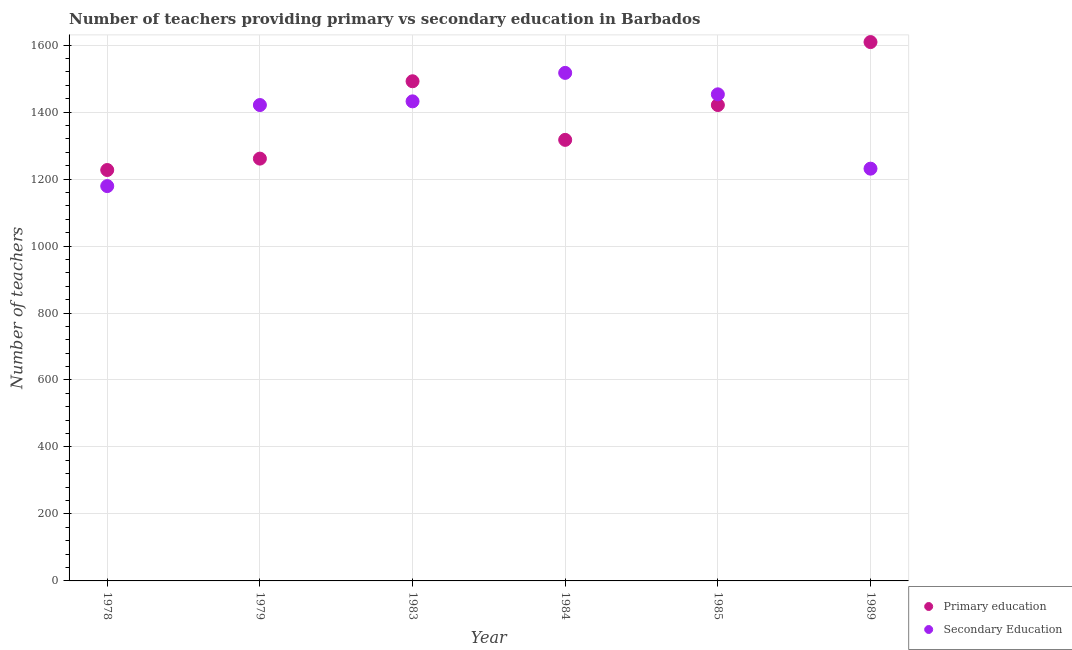How many different coloured dotlines are there?
Your response must be concise. 2. Is the number of dotlines equal to the number of legend labels?
Keep it short and to the point. Yes. What is the number of secondary teachers in 1979?
Make the answer very short. 1421. Across all years, what is the maximum number of primary teachers?
Your answer should be very brief. 1609. Across all years, what is the minimum number of secondary teachers?
Offer a terse response. 1179. In which year was the number of secondary teachers maximum?
Ensure brevity in your answer.  1984. In which year was the number of primary teachers minimum?
Make the answer very short. 1978. What is the total number of secondary teachers in the graph?
Your response must be concise. 8233. What is the difference between the number of primary teachers in 1979 and that in 1985?
Your answer should be compact. -160. What is the difference between the number of secondary teachers in 1989 and the number of primary teachers in 1978?
Provide a short and direct response. 4. What is the average number of primary teachers per year?
Provide a succinct answer. 1387.83. In the year 1989, what is the difference between the number of secondary teachers and number of primary teachers?
Your answer should be compact. -378. In how many years, is the number of secondary teachers greater than 1040?
Give a very brief answer. 6. What is the ratio of the number of primary teachers in 1978 to that in 1983?
Your answer should be very brief. 0.82. Is the difference between the number of secondary teachers in 1978 and 1985 greater than the difference between the number of primary teachers in 1978 and 1985?
Your answer should be compact. No. What is the difference between the highest and the second highest number of primary teachers?
Give a very brief answer. 117. What is the difference between the highest and the lowest number of primary teachers?
Your answer should be very brief. 382. Is the sum of the number of secondary teachers in 1978 and 1983 greater than the maximum number of primary teachers across all years?
Make the answer very short. Yes. Does the number of primary teachers monotonically increase over the years?
Offer a terse response. No. Is the number of primary teachers strictly greater than the number of secondary teachers over the years?
Ensure brevity in your answer.  No. Is the number of secondary teachers strictly less than the number of primary teachers over the years?
Provide a short and direct response. No. How many dotlines are there?
Offer a very short reply. 2. Are the values on the major ticks of Y-axis written in scientific E-notation?
Make the answer very short. No. Does the graph contain grids?
Your response must be concise. Yes. How many legend labels are there?
Offer a terse response. 2. How are the legend labels stacked?
Your answer should be compact. Vertical. What is the title of the graph?
Provide a succinct answer. Number of teachers providing primary vs secondary education in Barbados. What is the label or title of the Y-axis?
Offer a terse response. Number of teachers. What is the Number of teachers of Primary education in 1978?
Give a very brief answer. 1227. What is the Number of teachers of Secondary Education in 1978?
Offer a very short reply. 1179. What is the Number of teachers of Primary education in 1979?
Give a very brief answer. 1261. What is the Number of teachers in Secondary Education in 1979?
Make the answer very short. 1421. What is the Number of teachers in Primary education in 1983?
Your response must be concise. 1492. What is the Number of teachers of Secondary Education in 1983?
Give a very brief answer. 1432. What is the Number of teachers in Primary education in 1984?
Your answer should be compact. 1317. What is the Number of teachers of Secondary Education in 1984?
Your response must be concise. 1517. What is the Number of teachers of Primary education in 1985?
Offer a terse response. 1421. What is the Number of teachers of Secondary Education in 1985?
Give a very brief answer. 1453. What is the Number of teachers of Primary education in 1989?
Your answer should be compact. 1609. What is the Number of teachers of Secondary Education in 1989?
Offer a very short reply. 1231. Across all years, what is the maximum Number of teachers of Primary education?
Your response must be concise. 1609. Across all years, what is the maximum Number of teachers in Secondary Education?
Make the answer very short. 1517. Across all years, what is the minimum Number of teachers in Primary education?
Give a very brief answer. 1227. Across all years, what is the minimum Number of teachers of Secondary Education?
Provide a succinct answer. 1179. What is the total Number of teachers of Primary education in the graph?
Your response must be concise. 8327. What is the total Number of teachers in Secondary Education in the graph?
Your response must be concise. 8233. What is the difference between the Number of teachers in Primary education in 1978 and that in 1979?
Offer a terse response. -34. What is the difference between the Number of teachers of Secondary Education in 1978 and that in 1979?
Your answer should be very brief. -242. What is the difference between the Number of teachers of Primary education in 1978 and that in 1983?
Ensure brevity in your answer.  -265. What is the difference between the Number of teachers of Secondary Education in 1978 and that in 1983?
Your answer should be very brief. -253. What is the difference between the Number of teachers of Primary education in 1978 and that in 1984?
Ensure brevity in your answer.  -90. What is the difference between the Number of teachers of Secondary Education in 1978 and that in 1984?
Make the answer very short. -338. What is the difference between the Number of teachers of Primary education in 1978 and that in 1985?
Provide a short and direct response. -194. What is the difference between the Number of teachers of Secondary Education in 1978 and that in 1985?
Keep it short and to the point. -274. What is the difference between the Number of teachers in Primary education in 1978 and that in 1989?
Give a very brief answer. -382. What is the difference between the Number of teachers of Secondary Education in 1978 and that in 1989?
Ensure brevity in your answer.  -52. What is the difference between the Number of teachers in Primary education in 1979 and that in 1983?
Give a very brief answer. -231. What is the difference between the Number of teachers in Primary education in 1979 and that in 1984?
Ensure brevity in your answer.  -56. What is the difference between the Number of teachers of Secondary Education in 1979 and that in 1984?
Ensure brevity in your answer.  -96. What is the difference between the Number of teachers in Primary education in 1979 and that in 1985?
Offer a terse response. -160. What is the difference between the Number of teachers in Secondary Education in 1979 and that in 1985?
Provide a succinct answer. -32. What is the difference between the Number of teachers in Primary education in 1979 and that in 1989?
Make the answer very short. -348. What is the difference between the Number of teachers in Secondary Education in 1979 and that in 1989?
Offer a terse response. 190. What is the difference between the Number of teachers of Primary education in 1983 and that in 1984?
Your response must be concise. 175. What is the difference between the Number of teachers in Secondary Education in 1983 and that in 1984?
Offer a terse response. -85. What is the difference between the Number of teachers in Secondary Education in 1983 and that in 1985?
Keep it short and to the point. -21. What is the difference between the Number of teachers in Primary education in 1983 and that in 1989?
Ensure brevity in your answer.  -117. What is the difference between the Number of teachers in Secondary Education in 1983 and that in 1989?
Your answer should be very brief. 201. What is the difference between the Number of teachers in Primary education in 1984 and that in 1985?
Provide a succinct answer. -104. What is the difference between the Number of teachers in Secondary Education in 1984 and that in 1985?
Provide a succinct answer. 64. What is the difference between the Number of teachers of Primary education in 1984 and that in 1989?
Make the answer very short. -292. What is the difference between the Number of teachers of Secondary Education in 1984 and that in 1989?
Give a very brief answer. 286. What is the difference between the Number of teachers of Primary education in 1985 and that in 1989?
Your answer should be very brief. -188. What is the difference between the Number of teachers of Secondary Education in 1985 and that in 1989?
Provide a short and direct response. 222. What is the difference between the Number of teachers in Primary education in 1978 and the Number of teachers in Secondary Education in 1979?
Provide a succinct answer. -194. What is the difference between the Number of teachers in Primary education in 1978 and the Number of teachers in Secondary Education in 1983?
Make the answer very short. -205. What is the difference between the Number of teachers of Primary education in 1978 and the Number of teachers of Secondary Education in 1984?
Your answer should be compact. -290. What is the difference between the Number of teachers in Primary education in 1978 and the Number of teachers in Secondary Education in 1985?
Your answer should be compact. -226. What is the difference between the Number of teachers of Primary education in 1979 and the Number of teachers of Secondary Education in 1983?
Keep it short and to the point. -171. What is the difference between the Number of teachers in Primary education in 1979 and the Number of teachers in Secondary Education in 1984?
Make the answer very short. -256. What is the difference between the Number of teachers in Primary education in 1979 and the Number of teachers in Secondary Education in 1985?
Give a very brief answer. -192. What is the difference between the Number of teachers of Primary education in 1979 and the Number of teachers of Secondary Education in 1989?
Ensure brevity in your answer.  30. What is the difference between the Number of teachers of Primary education in 1983 and the Number of teachers of Secondary Education in 1989?
Offer a very short reply. 261. What is the difference between the Number of teachers in Primary education in 1984 and the Number of teachers in Secondary Education in 1985?
Make the answer very short. -136. What is the difference between the Number of teachers in Primary education in 1984 and the Number of teachers in Secondary Education in 1989?
Give a very brief answer. 86. What is the difference between the Number of teachers in Primary education in 1985 and the Number of teachers in Secondary Education in 1989?
Ensure brevity in your answer.  190. What is the average Number of teachers of Primary education per year?
Provide a succinct answer. 1387.83. What is the average Number of teachers of Secondary Education per year?
Make the answer very short. 1372.17. In the year 1978, what is the difference between the Number of teachers of Primary education and Number of teachers of Secondary Education?
Provide a short and direct response. 48. In the year 1979, what is the difference between the Number of teachers of Primary education and Number of teachers of Secondary Education?
Ensure brevity in your answer.  -160. In the year 1984, what is the difference between the Number of teachers in Primary education and Number of teachers in Secondary Education?
Make the answer very short. -200. In the year 1985, what is the difference between the Number of teachers of Primary education and Number of teachers of Secondary Education?
Provide a succinct answer. -32. In the year 1989, what is the difference between the Number of teachers in Primary education and Number of teachers in Secondary Education?
Your answer should be very brief. 378. What is the ratio of the Number of teachers of Primary education in 1978 to that in 1979?
Make the answer very short. 0.97. What is the ratio of the Number of teachers in Secondary Education in 1978 to that in 1979?
Provide a short and direct response. 0.83. What is the ratio of the Number of teachers in Primary education in 1978 to that in 1983?
Offer a very short reply. 0.82. What is the ratio of the Number of teachers in Secondary Education in 1978 to that in 1983?
Give a very brief answer. 0.82. What is the ratio of the Number of teachers in Primary education in 1978 to that in 1984?
Provide a short and direct response. 0.93. What is the ratio of the Number of teachers in Secondary Education in 1978 to that in 1984?
Offer a very short reply. 0.78. What is the ratio of the Number of teachers in Primary education in 1978 to that in 1985?
Offer a terse response. 0.86. What is the ratio of the Number of teachers of Secondary Education in 1978 to that in 1985?
Keep it short and to the point. 0.81. What is the ratio of the Number of teachers of Primary education in 1978 to that in 1989?
Offer a very short reply. 0.76. What is the ratio of the Number of teachers in Secondary Education in 1978 to that in 1989?
Your response must be concise. 0.96. What is the ratio of the Number of teachers in Primary education in 1979 to that in 1983?
Make the answer very short. 0.85. What is the ratio of the Number of teachers in Primary education in 1979 to that in 1984?
Offer a terse response. 0.96. What is the ratio of the Number of teachers of Secondary Education in 1979 to that in 1984?
Ensure brevity in your answer.  0.94. What is the ratio of the Number of teachers of Primary education in 1979 to that in 1985?
Your answer should be compact. 0.89. What is the ratio of the Number of teachers of Secondary Education in 1979 to that in 1985?
Offer a terse response. 0.98. What is the ratio of the Number of teachers in Primary education in 1979 to that in 1989?
Provide a succinct answer. 0.78. What is the ratio of the Number of teachers of Secondary Education in 1979 to that in 1989?
Your answer should be very brief. 1.15. What is the ratio of the Number of teachers of Primary education in 1983 to that in 1984?
Make the answer very short. 1.13. What is the ratio of the Number of teachers of Secondary Education in 1983 to that in 1984?
Provide a succinct answer. 0.94. What is the ratio of the Number of teachers of Primary education in 1983 to that in 1985?
Provide a short and direct response. 1.05. What is the ratio of the Number of teachers in Secondary Education in 1983 to that in 1985?
Provide a succinct answer. 0.99. What is the ratio of the Number of teachers of Primary education in 1983 to that in 1989?
Your response must be concise. 0.93. What is the ratio of the Number of teachers in Secondary Education in 1983 to that in 1989?
Keep it short and to the point. 1.16. What is the ratio of the Number of teachers in Primary education in 1984 to that in 1985?
Make the answer very short. 0.93. What is the ratio of the Number of teachers of Secondary Education in 1984 to that in 1985?
Give a very brief answer. 1.04. What is the ratio of the Number of teachers of Primary education in 1984 to that in 1989?
Make the answer very short. 0.82. What is the ratio of the Number of teachers of Secondary Education in 1984 to that in 1989?
Offer a very short reply. 1.23. What is the ratio of the Number of teachers of Primary education in 1985 to that in 1989?
Provide a succinct answer. 0.88. What is the ratio of the Number of teachers of Secondary Education in 1985 to that in 1989?
Your response must be concise. 1.18. What is the difference between the highest and the second highest Number of teachers of Primary education?
Offer a terse response. 117. What is the difference between the highest and the lowest Number of teachers of Primary education?
Provide a succinct answer. 382. What is the difference between the highest and the lowest Number of teachers in Secondary Education?
Your response must be concise. 338. 